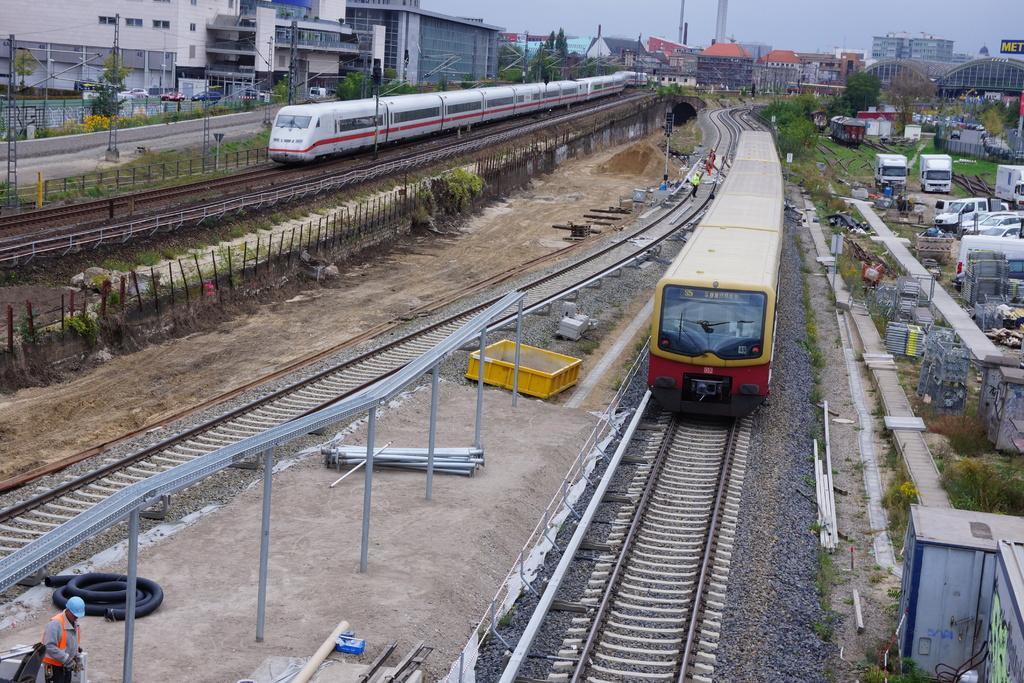How would you summarize this image in a sentence or two? In this image I can see two trains on the railway track. I can see pipes,poles,few people,trees,building,grass,vehicles. The sky is in blue and white color. 